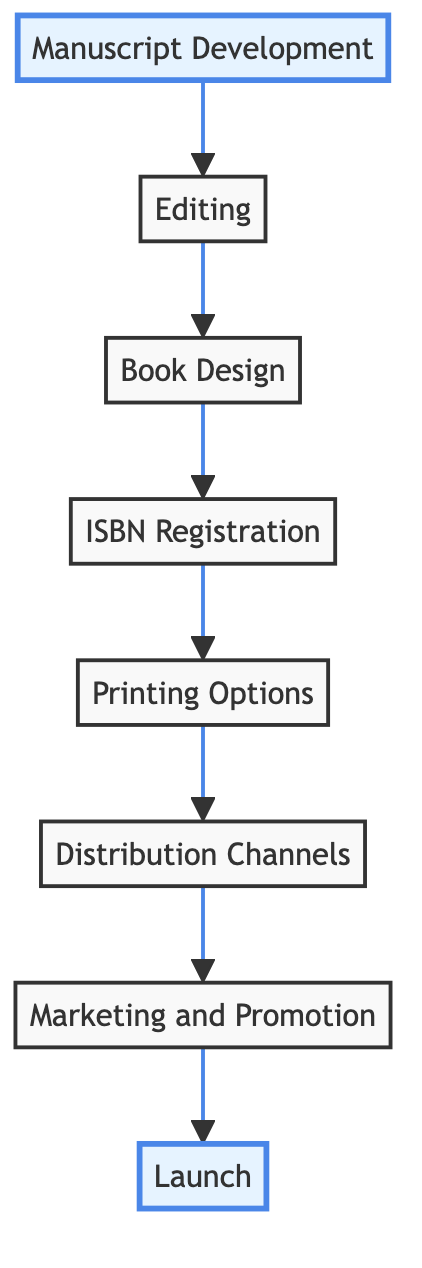What is the first step in the publishing process? The first node in the flowchart is "Manuscript Development", indicating that the initial step is to draft and refine the content of the book.
Answer: Manuscript Development How many total steps are outlined in the publishing process? By counting each distinct node in the diagram from "Manuscript Development" to "Launch", there are a total of 8 steps in the publishing process.
Answer: 8 What is the last step in the book publishing process? The final node in the flowchart is "Launch", which indicates the step where the book is officially released to the public.
Answer: Launch Which step follows "ISBN Registration"? Looking at the flow of the diagram, the step that comes after "ISBN Registration" is "Printing Options".
Answer: Printing Options What is the relationship between "Editing" and "Book Design"? According to the flowchart, "Editing" directly leads to "Book Design", meaning "Editing" is a prerequisite before moving on to "Book Design".
Answer: Directly leads to Which step includes developing a marketing strategy? The node titled "Marketing and Promotion" describes the step that involves developing a marketing strategy to reach the target audience.
Answer: Marketing and Promotion What are the two options listed under "Printing Options"? The "Printing Options" node does not specify exact options but implies the choice between print on demand or bulk printing as its choices.
Answer: Print on demand or bulk printing How does "Distribution Channels" relate to "Launch"? In the flowchart, "Distribution Channels" comes before "Launch", meaning after selecting distribution channels, the next action is to launch the book.
Answer: Comes before Which step requires obtaining an ISBN? The node specifically labeled "ISBN Registration" indicates that this step involves obtaining an International Standard Book Number for the book.
Answer: ISBN Registration 